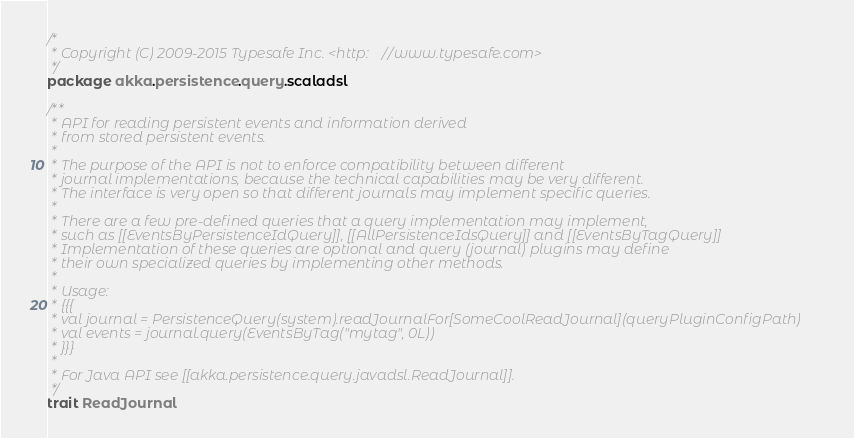Convert code to text. <code><loc_0><loc_0><loc_500><loc_500><_Scala_>/*
 * Copyright (C) 2009-2015 Typesafe Inc. <http://www.typesafe.com>
 */
package akka.persistence.query.scaladsl

/**
 * API for reading persistent events and information derived
 * from stored persistent events.
 *
 * The purpose of the API is not to enforce compatibility between different
 * journal implementations, because the technical capabilities may be very different.
 * The interface is very open so that different journals may implement specific queries.
 *
 * There are a few pre-defined queries that a query implementation may implement,
 * such as [[EventsByPersistenceIdQuery]], [[AllPersistenceIdsQuery]] and [[EventsByTagQuery]]
 * Implementation of these queries are optional and query (journal) plugins may define
 * their own specialized queries by implementing other methods.
 *
 * Usage:
 * {{{
 * val journal = PersistenceQuery(system).readJournalFor[SomeCoolReadJournal](queryPluginConfigPath)
 * val events = journal.query(EventsByTag("mytag", 0L))
 * }}}
 *
 * For Java API see [[akka.persistence.query.javadsl.ReadJournal]].
 */
trait ReadJournal

</code> 